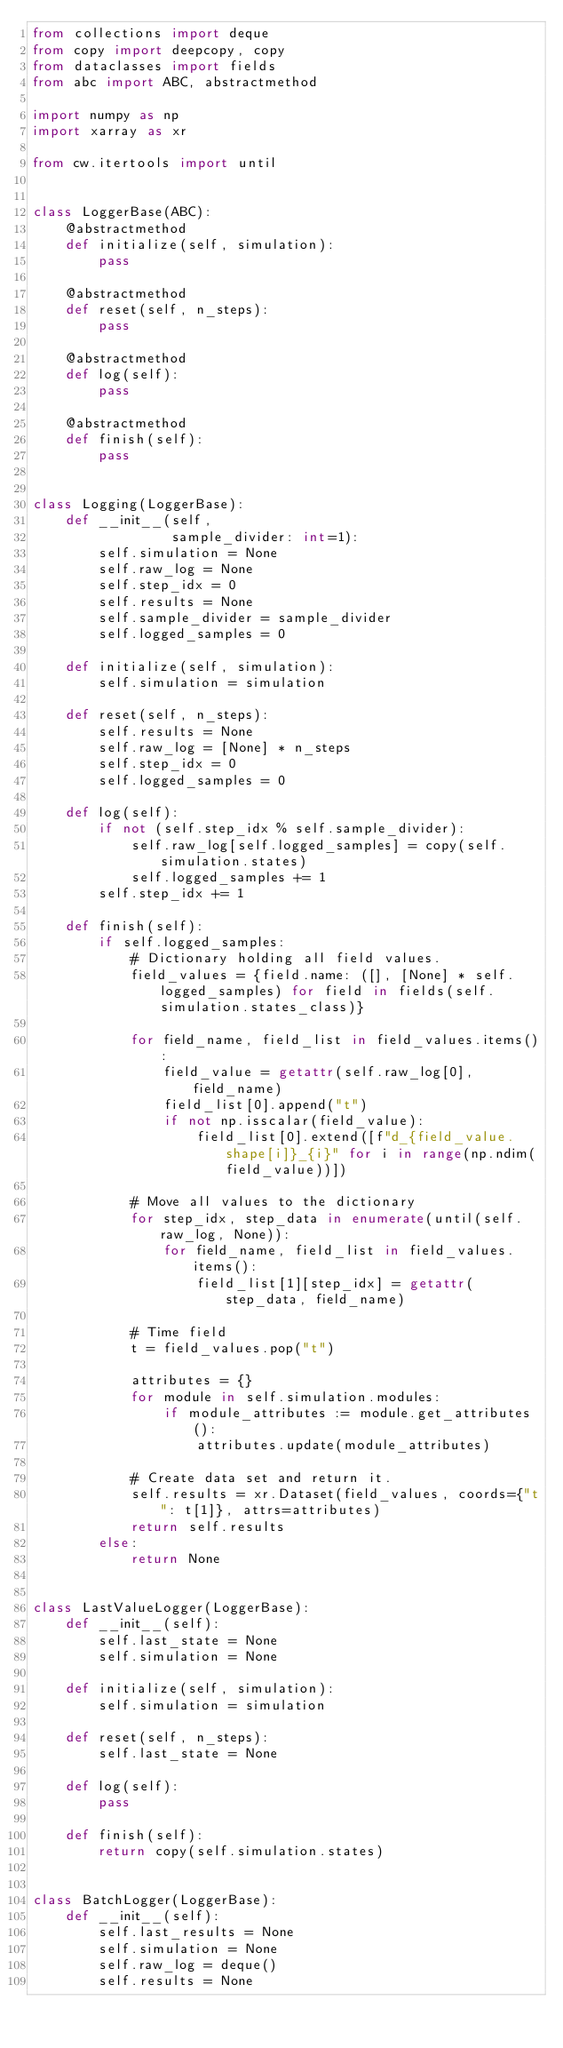<code> <loc_0><loc_0><loc_500><loc_500><_Python_>from collections import deque
from copy import deepcopy, copy
from dataclasses import fields
from abc import ABC, abstractmethod

import numpy as np
import xarray as xr

from cw.itertools import until


class LoggerBase(ABC):
    @abstractmethod
    def initialize(self, simulation):
        pass

    @abstractmethod
    def reset(self, n_steps):
        pass

    @abstractmethod
    def log(self):
        pass

    @abstractmethod
    def finish(self):
        pass


class Logging(LoggerBase):
    def __init__(self,
                 sample_divider: int=1):
        self.simulation = None
        self.raw_log = None
        self.step_idx = 0
        self.results = None
        self.sample_divider = sample_divider
        self.logged_samples = 0

    def initialize(self, simulation):
        self.simulation = simulation

    def reset(self, n_steps):
        self.results = None
        self.raw_log = [None] * n_steps
        self.step_idx = 0
        self.logged_samples = 0

    def log(self):
        if not (self.step_idx % self.sample_divider):
            self.raw_log[self.logged_samples] = copy(self.simulation.states)
            self.logged_samples += 1
        self.step_idx += 1

    def finish(self):
        if self.logged_samples:
            # Dictionary holding all field values.
            field_values = {field.name: ([], [None] * self.logged_samples) for field in fields(self.simulation.states_class)}

            for field_name, field_list in field_values.items():
                field_value = getattr(self.raw_log[0], field_name)
                field_list[0].append("t")
                if not np.isscalar(field_value):
                    field_list[0].extend([f"d_{field_value.shape[i]}_{i}" for i in range(np.ndim(field_value))])

            # Move all values to the dictionary
            for step_idx, step_data in enumerate(until(self.raw_log, None)):
                for field_name, field_list in field_values.items():
                    field_list[1][step_idx] = getattr(step_data, field_name)

            # Time field
            t = field_values.pop("t")

            attributes = {}
            for module in self.simulation.modules:
                if module_attributes := module.get_attributes():
                    attributes.update(module_attributes)

            # Create data set and return it.
            self.results = xr.Dataset(field_values, coords={"t": t[1]}, attrs=attributes)
            return self.results
        else:
            return None


class LastValueLogger(LoggerBase):
    def __init__(self):
        self.last_state = None
        self.simulation = None

    def initialize(self, simulation):
        self.simulation = simulation

    def reset(self, n_steps):
        self.last_state = None

    def log(self):
        pass

    def finish(self):
        return copy(self.simulation.states)


class BatchLogger(LoggerBase):
    def __init__(self):
        self.last_results = None
        self.simulation = None
        self.raw_log = deque()
        self.results = None
</code> 